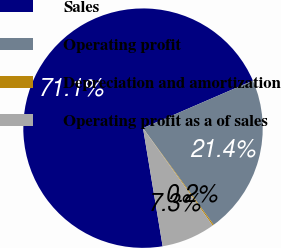Convert chart. <chart><loc_0><loc_0><loc_500><loc_500><pie_chart><fcel>Sales<fcel>Operating profit<fcel>Depreciation and amortization<fcel>Operating profit as a of sales<nl><fcel>71.12%<fcel>21.45%<fcel>0.17%<fcel>7.26%<nl></chart> 